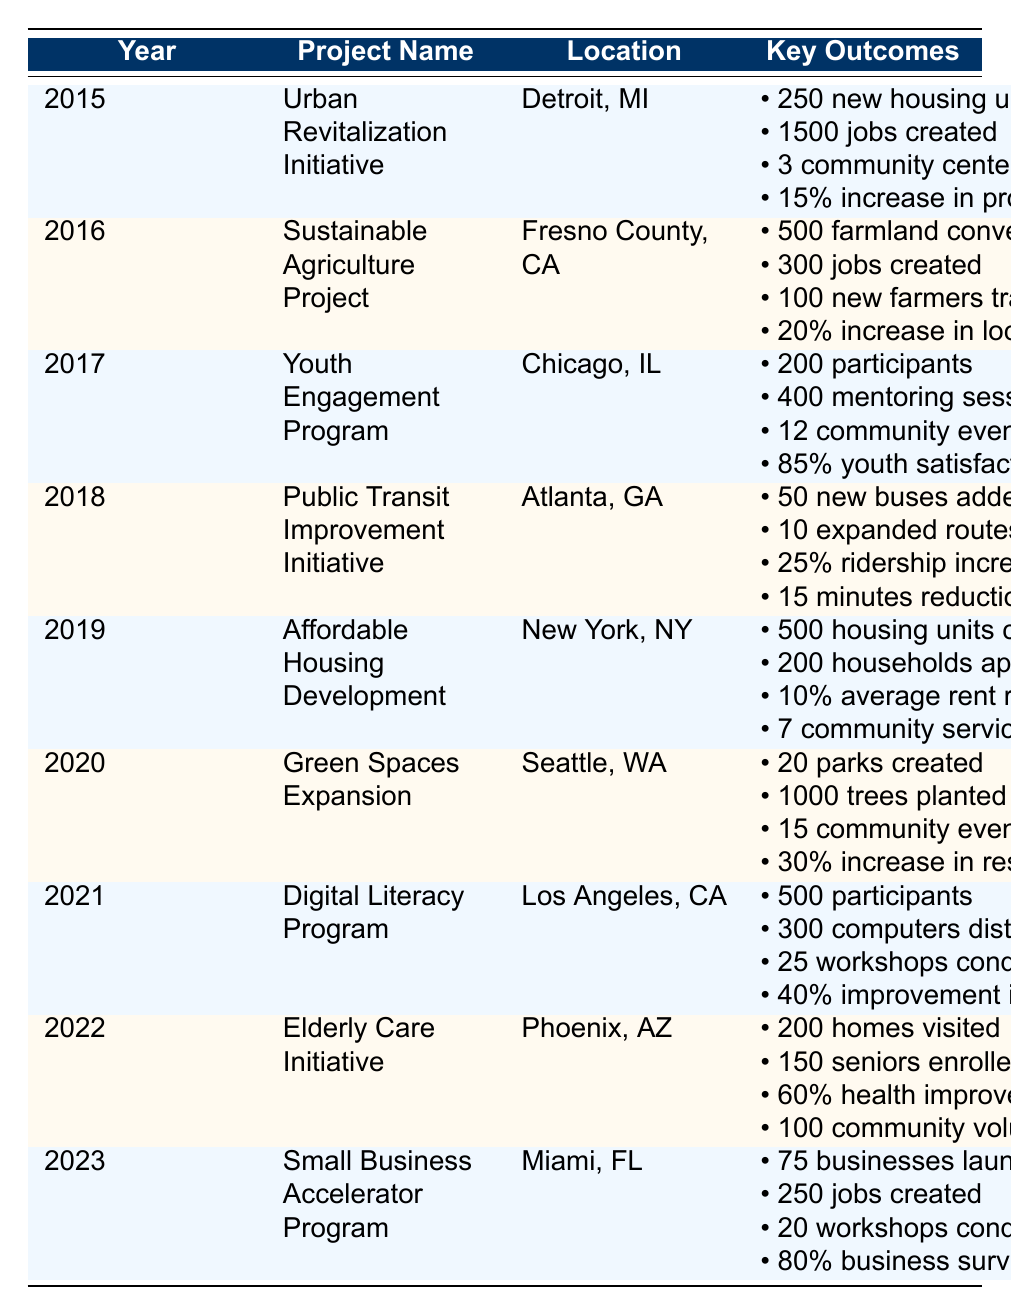What project aimed at job creation took place in 2015? The table shows that the "Urban Revitalization Initiative" in Detroit, MI had an outcome of 1500 jobs created in 2015.
Answer: Urban Revitalization Initiative How many new housing units were created in the Affordable Housing Development project? The outcome for the Affordable Housing Development project in 2019 states that 500 housing units were completed.
Answer: 500 Which project had the highest percentage increase in satisfaction related to community services? The Green Spaces Expansion project in 2020 reported a 30% increase in resident satisfaction, which is the highest reported in the table.
Answer: 30% Did the Digital Literacy Program have a positive impact on job placement rates? Yes, the Digital Literacy Program in 2021 showed a 40% improvement in job placement rates, indicating a positive impact.
Answer: Yes What was the average number of new housing units created per project from 2015 to 2019? The new housing units created during this period were 250 (2015) + 500 (2019) = 750 for two projects; averaging gives 750/2 = 375.
Answer: 375 Which project had the lowest number of community events hosted? The Youth Engagement Program in 2017 hosted 12 community events, the lowest in comparison to others.
Answer: 12 What was the increase in local food sales from the Sustainable Agriculture Project? The Sustainable Agriculture Project reported a 20% increase in local food sales in 2016.
Answer: 20% How many parks were created in the Green Spaces Expansion project? The outcome for the Green Spaces Expansion project in 2020 indicates that 20 parks were created.
Answer: 20 Which project had a higher survival rate for businesses, the Elderly Care Initiative or the Small Business Accelerator Program? The Small Business Accelerator Program reported an 80% business survival rate, while the Elderly Care Initiative does not mention any business survival rate, making it higher.
Answer: Small Business Accelerator Program What is the difference in job creation between the Urban Revitalization Initiative and the Digital Literacy Program? The Urban Revitalization Initiative created 1500 jobs, while the Digital Literacy Program created jobs with an improvement of 40%, but not a specific number. However, the Urban project has more definite job creation.
Answer: Urban Revitalization Initiative had more jobs created 